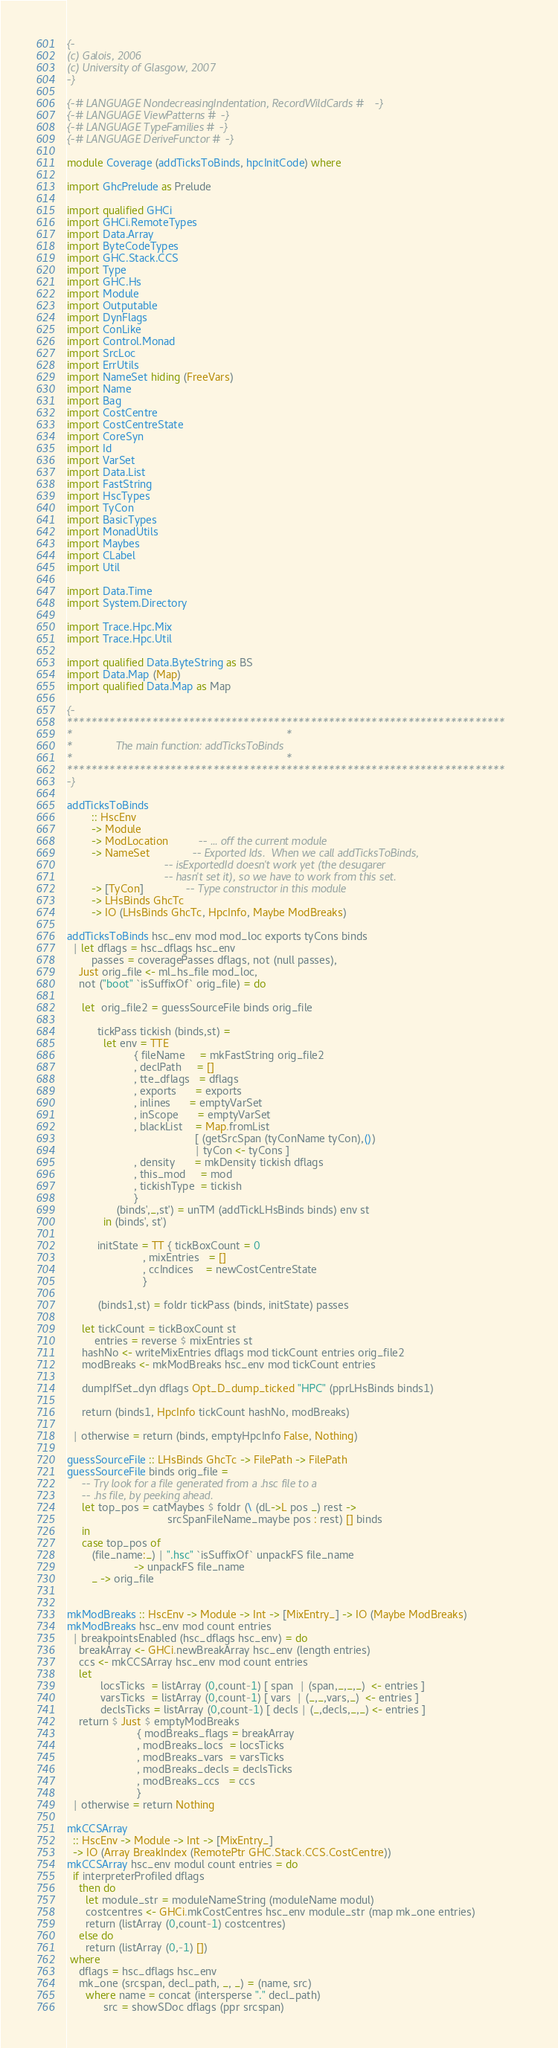<code> <loc_0><loc_0><loc_500><loc_500><_Haskell_>{-
(c) Galois, 2006
(c) University of Glasgow, 2007
-}

{-# LANGUAGE NondecreasingIndentation, RecordWildCards #-}
{-# LANGUAGE ViewPatterns #-}
{-# LANGUAGE TypeFamilies #-}
{-# LANGUAGE DeriveFunctor #-}

module Coverage (addTicksToBinds, hpcInitCode) where

import GhcPrelude as Prelude

import qualified GHCi
import GHCi.RemoteTypes
import Data.Array
import ByteCodeTypes
import GHC.Stack.CCS
import Type
import GHC.Hs
import Module
import Outputable
import DynFlags
import ConLike
import Control.Monad
import SrcLoc
import ErrUtils
import NameSet hiding (FreeVars)
import Name
import Bag
import CostCentre
import CostCentreState
import CoreSyn
import Id
import VarSet
import Data.List
import FastString
import HscTypes
import TyCon
import BasicTypes
import MonadUtils
import Maybes
import CLabel
import Util

import Data.Time
import System.Directory

import Trace.Hpc.Mix
import Trace.Hpc.Util

import qualified Data.ByteString as BS
import Data.Map (Map)
import qualified Data.Map as Map

{-
************************************************************************
*                                                                      *
*              The main function: addTicksToBinds
*                                                                      *
************************************************************************
-}

addTicksToBinds
        :: HscEnv
        -> Module
        -> ModLocation          -- ... off the current module
        -> NameSet              -- Exported Ids.  When we call addTicksToBinds,
                                -- isExportedId doesn't work yet (the desugarer
                                -- hasn't set it), so we have to work from this set.
        -> [TyCon]              -- Type constructor in this module
        -> LHsBinds GhcTc
        -> IO (LHsBinds GhcTc, HpcInfo, Maybe ModBreaks)

addTicksToBinds hsc_env mod mod_loc exports tyCons binds
  | let dflags = hsc_dflags hsc_env
        passes = coveragePasses dflags, not (null passes),
    Just orig_file <- ml_hs_file mod_loc,
    not ("boot" `isSuffixOf` orig_file) = do

     let  orig_file2 = guessSourceFile binds orig_file

          tickPass tickish (binds,st) =
            let env = TTE
                      { fileName     = mkFastString orig_file2
                      , declPath     = []
                      , tte_dflags   = dflags
                      , exports      = exports
                      , inlines      = emptyVarSet
                      , inScope      = emptyVarSet
                      , blackList    = Map.fromList
                                          [ (getSrcSpan (tyConName tyCon),())
                                          | tyCon <- tyCons ]
                      , density      = mkDensity tickish dflags
                      , this_mod     = mod
                      , tickishType  = tickish
                      }
                (binds',_,st') = unTM (addTickLHsBinds binds) env st
            in (binds', st')

          initState = TT { tickBoxCount = 0
                         , mixEntries   = []
                         , ccIndices    = newCostCentreState
                         }

          (binds1,st) = foldr tickPass (binds, initState) passes

     let tickCount = tickBoxCount st
         entries = reverse $ mixEntries st
     hashNo <- writeMixEntries dflags mod tickCount entries orig_file2
     modBreaks <- mkModBreaks hsc_env mod tickCount entries

     dumpIfSet_dyn dflags Opt_D_dump_ticked "HPC" (pprLHsBinds binds1)

     return (binds1, HpcInfo tickCount hashNo, modBreaks)

  | otherwise = return (binds, emptyHpcInfo False, Nothing)

guessSourceFile :: LHsBinds GhcTc -> FilePath -> FilePath
guessSourceFile binds orig_file =
     -- Try look for a file generated from a .hsc file to a
     -- .hs file, by peeking ahead.
     let top_pos = catMaybes $ foldr (\ (dL->L pos _) rest ->
                                 srcSpanFileName_maybe pos : rest) [] binds
     in
     case top_pos of
        (file_name:_) | ".hsc" `isSuffixOf` unpackFS file_name
                      -> unpackFS file_name
        _ -> orig_file


mkModBreaks :: HscEnv -> Module -> Int -> [MixEntry_] -> IO (Maybe ModBreaks)
mkModBreaks hsc_env mod count entries
  | breakpointsEnabled (hsc_dflags hsc_env) = do
    breakArray <- GHCi.newBreakArray hsc_env (length entries)
    ccs <- mkCCSArray hsc_env mod count entries
    let
           locsTicks  = listArray (0,count-1) [ span  | (span,_,_,_)  <- entries ]
           varsTicks  = listArray (0,count-1) [ vars  | (_,_,vars,_)  <- entries ]
           declsTicks = listArray (0,count-1) [ decls | (_,decls,_,_) <- entries ]
    return $ Just $ emptyModBreaks
                       { modBreaks_flags = breakArray
                       , modBreaks_locs  = locsTicks
                       , modBreaks_vars  = varsTicks
                       , modBreaks_decls = declsTicks
                       , modBreaks_ccs   = ccs
                       }
  | otherwise = return Nothing

mkCCSArray
  :: HscEnv -> Module -> Int -> [MixEntry_]
  -> IO (Array BreakIndex (RemotePtr GHC.Stack.CCS.CostCentre))
mkCCSArray hsc_env modul count entries = do
  if interpreterProfiled dflags
    then do
      let module_str = moduleNameString (moduleName modul)
      costcentres <- GHCi.mkCostCentres hsc_env module_str (map mk_one entries)
      return (listArray (0,count-1) costcentres)
    else do
      return (listArray (0,-1) [])
 where
    dflags = hsc_dflags hsc_env
    mk_one (srcspan, decl_path, _, _) = (name, src)
      where name = concat (intersperse "." decl_path)
            src = showSDoc dflags (ppr srcspan)

</code> 